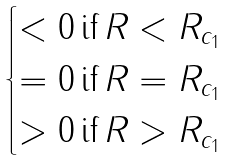Convert formula to latex. <formula><loc_0><loc_0><loc_500><loc_500>\begin{cases} < 0 \, \text {if} \, R < R _ { c _ { 1 } } \\ = 0 \, \text {if} \, R = R _ { c _ { 1 } } \\ > 0 \, \text {if} \, R > R _ { c _ { 1 } } \end{cases}</formula> 